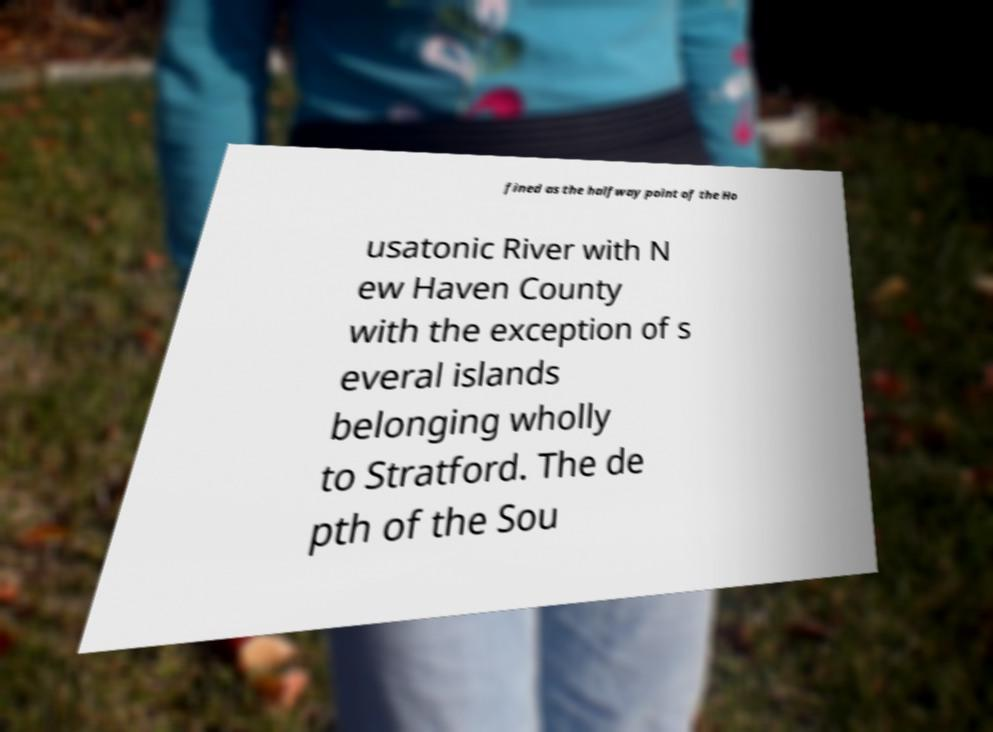Can you read and provide the text displayed in the image?This photo seems to have some interesting text. Can you extract and type it out for me? fined as the halfway point of the Ho usatonic River with N ew Haven County with the exception of s everal islands belonging wholly to Stratford. The de pth of the Sou 